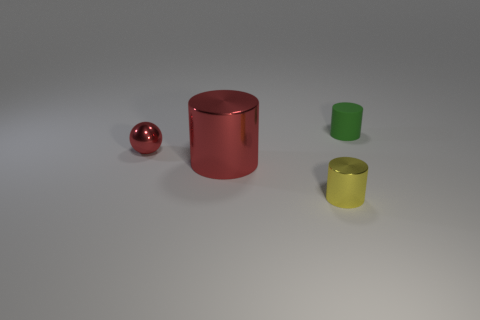Add 3 big red metallic balls. How many objects exist? 7 Subtract all small cylinders. How many cylinders are left? 1 Subtract all green cylinders. How many cylinders are left? 2 Subtract 0 brown cubes. How many objects are left? 4 Subtract all cylinders. How many objects are left? 1 Subtract 3 cylinders. How many cylinders are left? 0 Subtract all yellow cylinders. Subtract all gray spheres. How many cylinders are left? 2 Subtract all yellow cylinders. Subtract all green cylinders. How many objects are left? 2 Add 4 red cylinders. How many red cylinders are left? 5 Add 4 small matte cylinders. How many small matte cylinders exist? 5 